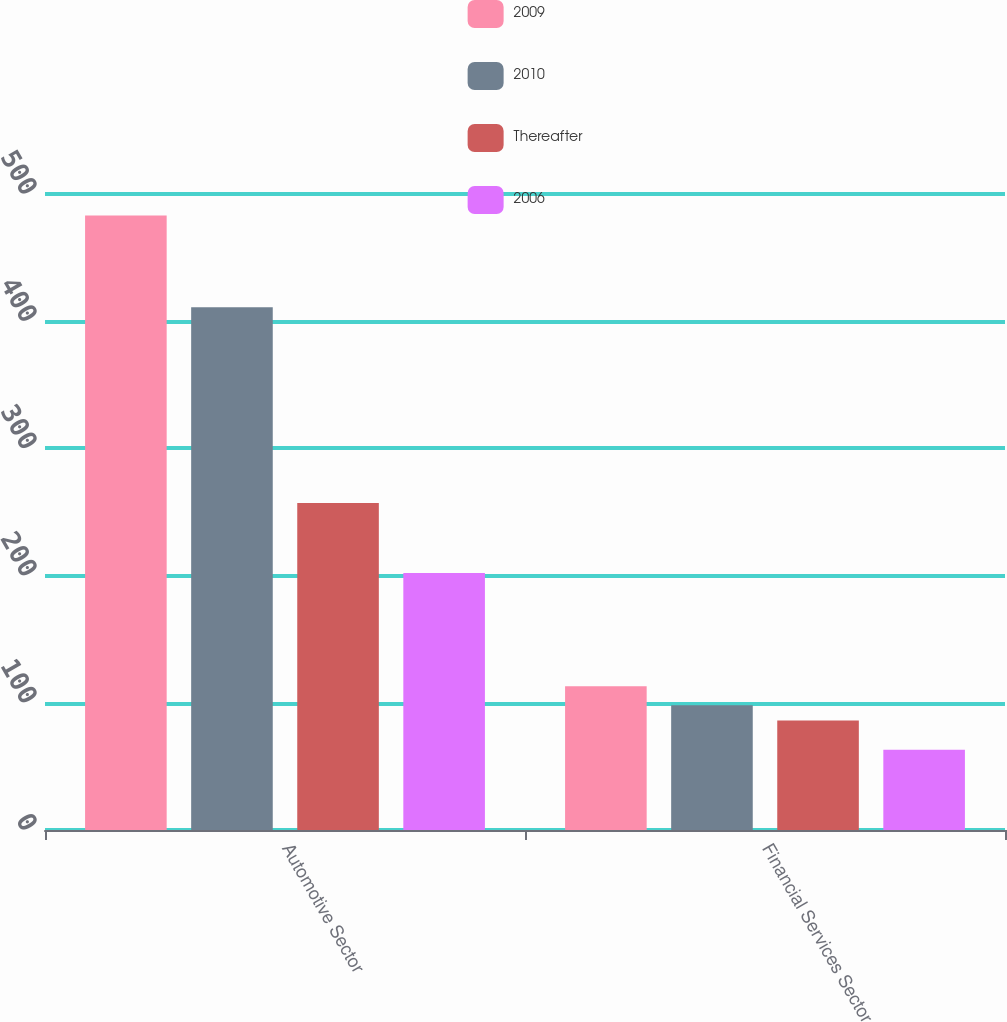Convert chart to OTSL. <chart><loc_0><loc_0><loc_500><loc_500><stacked_bar_chart><ecel><fcel>Automotive Sector<fcel>Financial Services Sector<nl><fcel>2009<fcel>483<fcel>113<nl><fcel>2010<fcel>411<fcel>98<nl><fcel>Thereafter<fcel>257<fcel>86<nl><fcel>2006<fcel>202<fcel>63<nl></chart> 